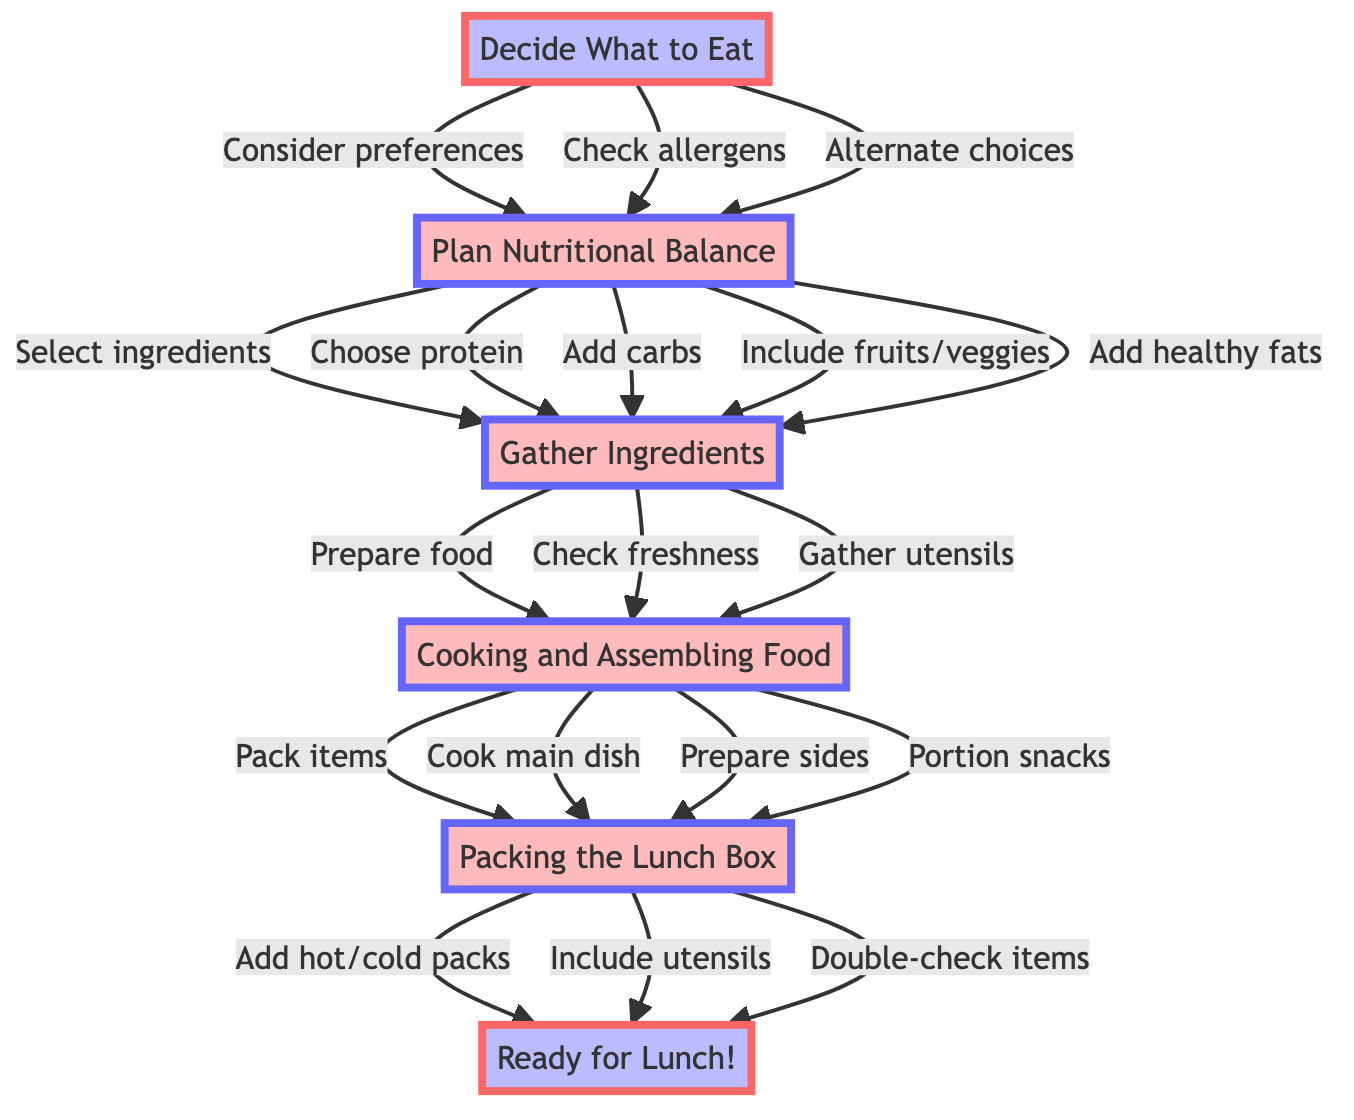What is the first step in the lunch preparation flow? The diagram indicates that the first step is "Decide What to Eat," as it starts from the bottom of the flow chart.
Answer: Decide What to Eat How many key steps are there in the lunch preparation process? By counting the elements detailed in the diagram, there are five key steps: "Decide What to Eat," "Plan Nutritional Balance," "Gather Ingredients," "Cooking and Assembling Food," and "Packing the Lunch Box."
Answer: Five What follows after "Gather Ingredients"? The flow chart shows that "Gather Ingredients" leads to "Cooking and Assembling Food," meaning it is the next step in the process after gathering the necessary ingredients.
Answer: Cooking and Assembling Food What item is included in the final packing step? The last step before the lunch is ready includes "Double-check that all items are included" as part of packing the lunch box, which is essential for confirming everything is packed.
Answer: Double-check that all items are included How are protein and carbohydrate chosen in the process? Protein and carbohydrate selection occurs during the "Plan Nutritional Balance" stage, where the diagram specifies the necessity to "Select a protein source" and "Choose a carbohydrate."
Answer: Plan Nutritional Balance What is included in the "Cooking and Assembling Food" step? In this step, the diagram details three specific actions: "Cook main dish," "Prepare side items," and "Portion snacks" that contribute to the assembly of the food.
Answer: Cook main dish, prepare side items, portion snacks What step involves checking for allergens? The diagram shows that checking for allergens occurs during the "Decide What to Eat" step, indicating it is one of the considerations during the decision-making process about meals.
Answer: Decide What to Eat Which two nodes have a direct connection with "Plan Nutritional Balance"? The two nodes that connect directly to "Plan Nutritional Balance" are "Decide What to Eat" and "Gather Ingredients," as both play a role in determining the nutritional content and ingredient selection.
Answer: Decide What to Eat, Gather Ingredients What intermediate step occurs before packing the lunch box? "Cooking and Assembling Food" is the intermediate step that takes place right before the final step of "Packing the Lunch Box," making it essential for meal preparation.
Answer: Cooking and Assembling Food 